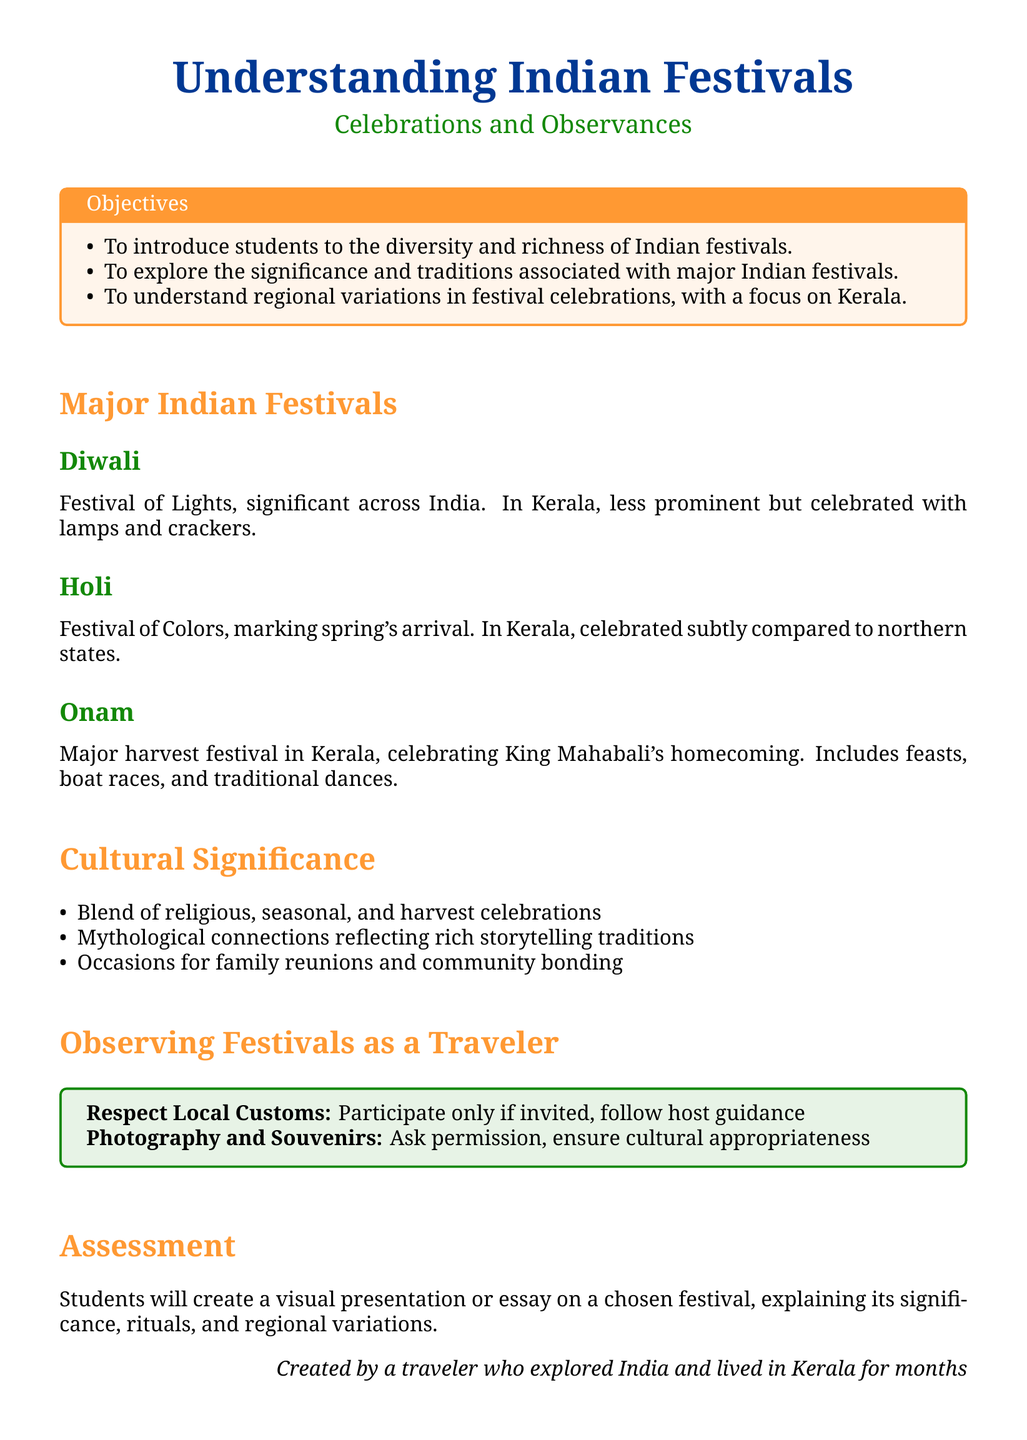What is the title of the lesson plan? The title of the lesson plan is "Understanding Indian Festivals".
Answer: Understanding Indian Festivals What is the main focus of the lesson plan? The main focus is on "Celebrations and Observances".
Answer: Celebrations and Observances What festival is celebrated as the Festival of Lights? The festival celebrated as the Festival of Lights is "Diwali".
Answer: Diwali Which festival is considered a major harvest festival in Kerala? The major harvest festival in Kerala is "Onam".
Answer: Onam What is one cultural significance mentioned in the document? One cultural significance is "family reunions".
Answer: family reunions What are students required to create for assessment? Students are required to create a "visual presentation or essay".
Answer: visual presentation or essay What should travelers do regarding local customs during festivals? Travelers should "participate only if invited".
Answer: participate only if invited How many major festivals are mentioned in the lesson plan? Three major festivals are mentioned: Diwali, Holi, and Onam.
Answer: Three What color is used for the title section of the document? The color used for the title section is "saffron".
Answer: saffron 